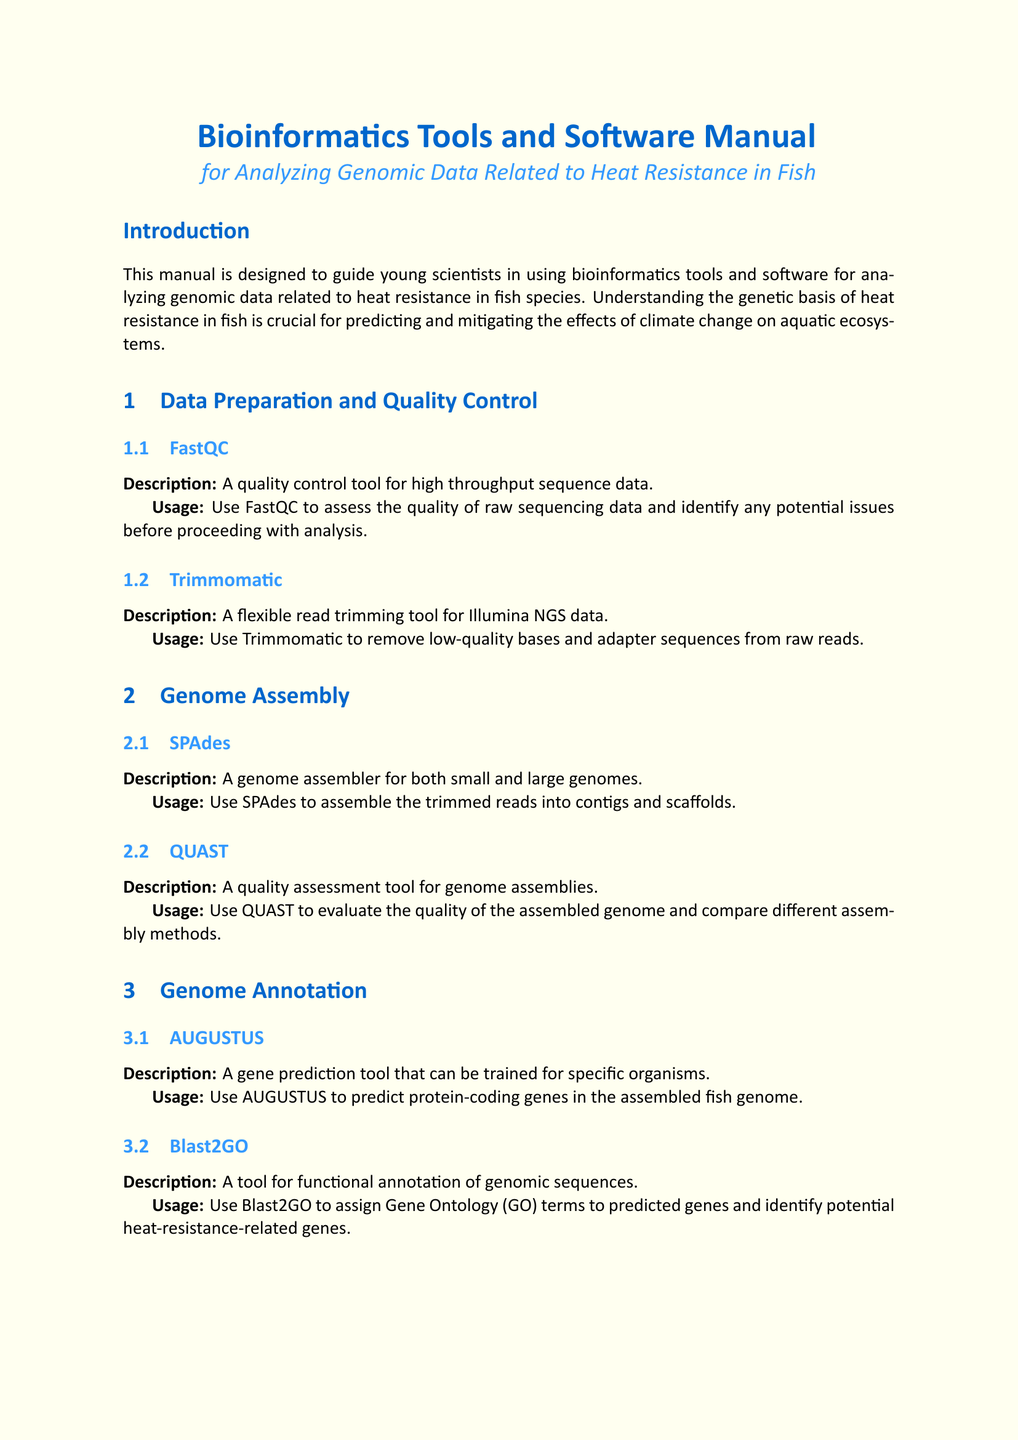What is the title of the manual? The title is mentioned at the beginning of the document, emphasizing its purpose.
Answer: Bioinformatics Tools and Software Manual for Analyzing Genomic Data Related to Heat Resistance in Fish How many sections are in the manual? Each section is clearly numbered in the document; counting them will give the total number of sections.
Answer: Eight What tool is used for quality control of sequencing data? The tool is listed in the Data Preparation and Quality Control section specifically for quality assessment.
Answer: FastQC Which tool is used to identify differentially expressed genes? This tool is specifically aimed at differential expression analysis and is mentioned in the Transcriptome Analysis section.
Answer: DESeq2 What is the usage purpose of DAVID? The tool's purpose in the manual is focused on functional analysis, as stated in the Functional Enrichment Analysis section.
Answer: Perform functional enrichment analysis What type of analysis can PAML perform? This information requires understanding the tool's capabilities mentioned in the Comparative Genomics section.
Answer: Phylogenetic analyses Which analysis tool helps visualize genomic data? This tool is highlighted for its visualization capabilities as stated in the Data Visualization section.
Answer: IGV (Integrative Genomics Viewer) What follows the conclusion in the manual? The conclusion section ends with a suggestion for future scientific exploration and methodologies.
Answer: Next steps 